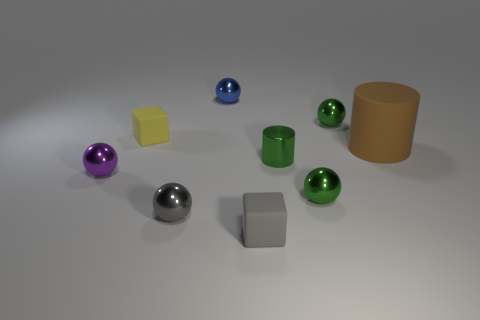Subtract all tiny purple spheres. How many spheres are left? 4 Subtract all green spheres. How many spheres are left? 3 Add 1 purple cylinders. How many objects exist? 10 Subtract 1 cylinders. How many cylinders are left? 1 Subtract all balls. How many objects are left? 4 Subtract all cyan cylinders. Subtract all gray spheres. How many cylinders are left? 2 Subtract all red blocks. How many green balls are left? 2 Subtract all big cyan rubber cylinders. Subtract all gray objects. How many objects are left? 7 Add 1 yellow matte cubes. How many yellow matte cubes are left? 2 Add 5 large brown things. How many large brown things exist? 6 